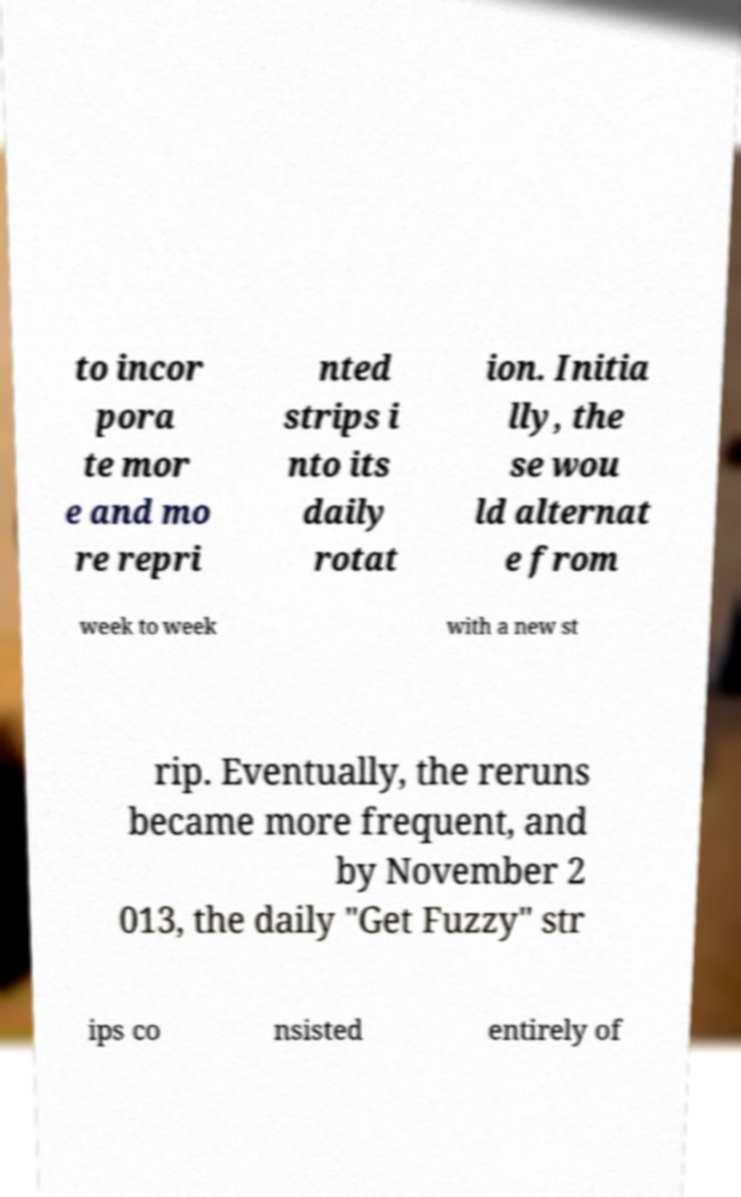Can you accurately transcribe the text from the provided image for me? to incor pora te mor e and mo re repri nted strips i nto its daily rotat ion. Initia lly, the se wou ld alternat e from week to week with a new st rip. Eventually, the reruns became more frequent, and by November 2 013, the daily "Get Fuzzy" str ips co nsisted entirely of 